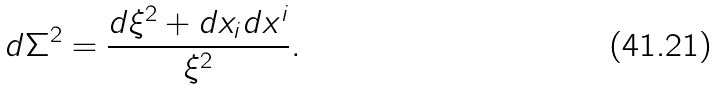<formula> <loc_0><loc_0><loc_500><loc_500>d \Sigma ^ { 2 } = \frac { d \xi ^ { 2 } + d x _ { i } d x ^ { i } } { \xi ^ { 2 } } .</formula> 